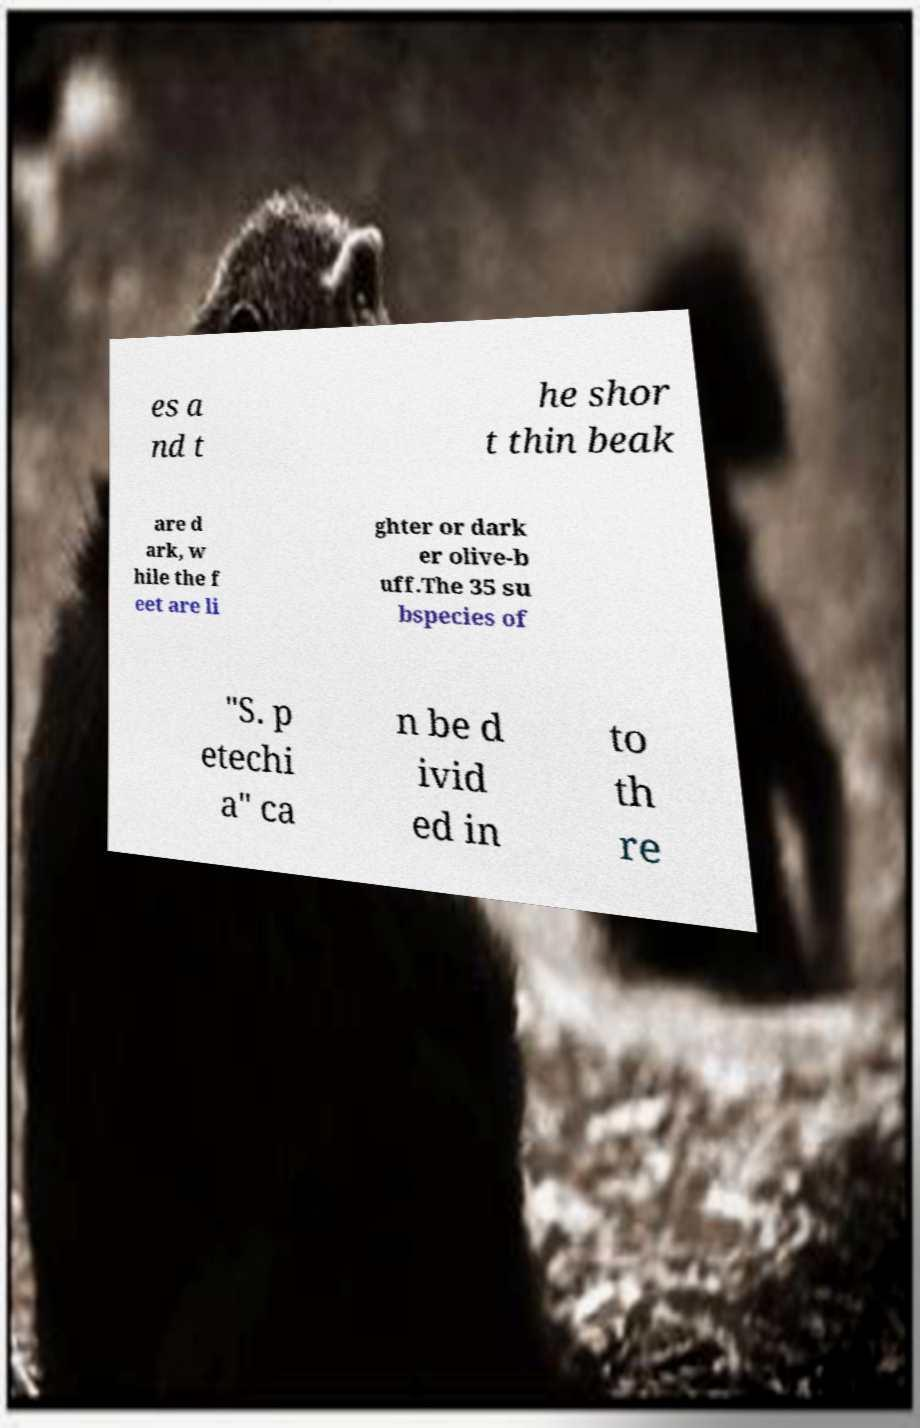Could you assist in decoding the text presented in this image and type it out clearly? es a nd t he shor t thin beak are d ark, w hile the f eet are li ghter or dark er olive-b uff.The 35 su bspecies of "S. p etechi a" ca n be d ivid ed in to th re 